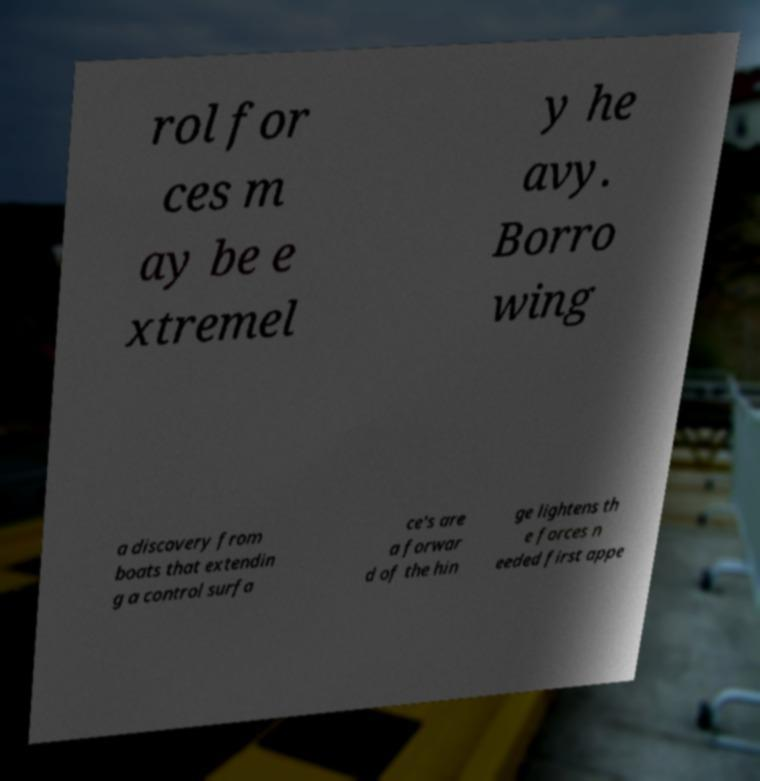Could you extract and type out the text from this image? rol for ces m ay be e xtremel y he avy. Borro wing a discovery from boats that extendin g a control surfa ce's are a forwar d of the hin ge lightens th e forces n eeded first appe 